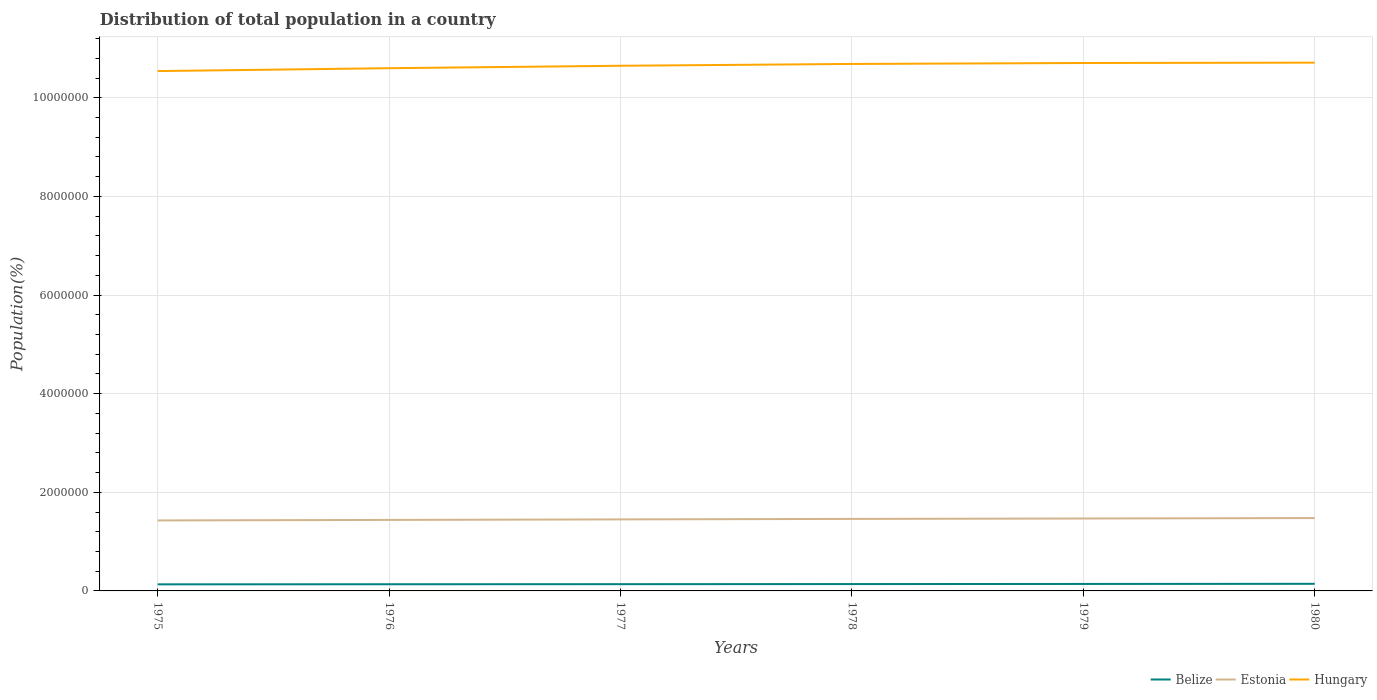Is the number of lines equal to the number of legend labels?
Your answer should be compact. Yes. Across all years, what is the maximum population of in Estonia?
Offer a very short reply. 1.43e+06. In which year was the population of in Estonia maximum?
Provide a short and direct response. 1975. What is the total population of in Belize in the graph?
Your answer should be very brief. -1.09e+04. What is the difference between the highest and the second highest population of in Belize?
Offer a terse response. 1.09e+04. Is the population of in Hungary strictly greater than the population of in Estonia over the years?
Offer a terse response. No. What is the difference between two consecutive major ticks on the Y-axis?
Give a very brief answer. 2.00e+06. How many legend labels are there?
Your answer should be very brief. 3. What is the title of the graph?
Provide a short and direct response. Distribution of total population in a country. What is the label or title of the Y-axis?
Give a very brief answer. Population(%). What is the Population(%) in Belize in 1975?
Your answer should be very brief. 1.33e+05. What is the Population(%) of Estonia in 1975?
Provide a succinct answer. 1.43e+06. What is the Population(%) in Hungary in 1975?
Provide a short and direct response. 1.05e+07. What is the Population(%) of Belize in 1976?
Offer a terse response. 1.35e+05. What is the Population(%) of Estonia in 1976?
Make the answer very short. 1.44e+06. What is the Population(%) in Hungary in 1976?
Ensure brevity in your answer.  1.06e+07. What is the Population(%) of Belize in 1977?
Give a very brief answer. 1.37e+05. What is the Population(%) in Estonia in 1977?
Your response must be concise. 1.45e+06. What is the Population(%) of Hungary in 1977?
Provide a short and direct response. 1.06e+07. What is the Population(%) in Belize in 1978?
Your answer should be very brief. 1.39e+05. What is the Population(%) of Estonia in 1978?
Your answer should be very brief. 1.46e+06. What is the Population(%) of Hungary in 1978?
Your answer should be compact. 1.07e+07. What is the Population(%) of Belize in 1979?
Offer a terse response. 1.41e+05. What is the Population(%) in Estonia in 1979?
Ensure brevity in your answer.  1.47e+06. What is the Population(%) in Hungary in 1979?
Make the answer very short. 1.07e+07. What is the Population(%) of Belize in 1980?
Give a very brief answer. 1.44e+05. What is the Population(%) in Estonia in 1980?
Your answer should be compact. 1.48e+06. What is the Population(%) of Hungary in 1980?
Offer a very short reply. 1.07e+07. Across all years, what is the maximum Population(%) in Belize?
Your answer should be compact. 1.44e+05. Across all years, what is the maximum Population(%) of Estonia?
Give a very brief answer. 1.48e+06. Across all years, what is the maximum Population(%) in Hungary?
Provide a succinct answer. 1.07e+07. Across all years, what is the minimum Population(%) of Belize?
Give a very brief answer. 1.33e+05. Across all years, what is the minimum Population(%) of Estonia?
Keep it short and to the point. 1.43e+06. Across all years, what is the minimum Population(%) of Hungary?
Ensure brevity in your answer.  1.05e+07. What is the total Population(%) of Belize in the graph?
Keep it short and to the point. 8.30e+05. What is the total Population(%) in Estonia in the graph?
Offer a terse response. 8.72e+06. What is the total Population(%) in Hungary in the graph?
Your answer should be compact. 6.39e+07. What is the difference between the Population(%) of Belize in 1975 and that in 1976?
Provide a short and direct response. -1884. What is the difference between the Population(%) in Estonia in 1975 and that in 1976?
Provide a short and direct response. -1.02e+04. What is the difference between the Population(%) in Hungary in 1975 and that in 1976?
Offer a terse response. -5.82e+04. What is the difference between the Population(%) of Belize in 1975 and that in 1977?
Your response must be concise. -3730. What is the difference between the Population(%) of Estonia in 1975 and that in 1977?
Provide a succinct answer. -2.09e+04. What is the difference between the Population(%) in Hungary in 1975 and that in 1977?
Make the answer very short. -1.08e+05. What is the difference between the Population(%) in Belize in 1975 and that in 1978?
Your answer should be compact. -5711. What is the difference between the Population(%) of Estonia in 1975 and that in 1978?
Keep it short and to the point. -3.08e+04. What is the difference between the Population(%) of Hungary in 1975 and that in 1978?
Provide a short and direct response. -1.44e+05. What is the difference between the Population(%) in Belize in 1975 and that in 1979?
Keep it short and to the point. -8047. What is the difference between the Population(%) of Estonia in 1975 and that in 1979?
Give a very brief answer. -3.90e+04. What is the difference between the Population(%) of Hungary in 1975 and that in 1979?
Give a very brief answer. -1.64e+05. What is the difference between the Population(%) in Belize in 1975 and that in 1980?
Provide a succinct answer. -1.09e+04. What is the difference between the Population(%) in Estonia in 1975 and that in 1980?
Make the answer very short. -4.79e+04. What is the difference between the Population(%) of Hungary in 1975 and that in 1980?
Give a very brief answer. -1.71e+05. What is the difference between the Population(%) in Belize in 1976 and that in 1977?
Provide a short and direct response. -1846. What is the difference between the Population(%) of Estonia in 1976 and that in 1977?
Provide a succinct answer. -1.06e+04. What is the difference between the Population(%) in Hungary in 1976 and that in 1977?
Your response must be concise. -4.94e+04. What is the difference between the Population(%) in Belize in 1976 and that in 1978?
Your answer should be very brief. -3827. What is the difference between the Population(%) of Estonia in 1976 and that in 1978?
Provide a short and direct response. -2.06e+04. What is the difference between the Population(%) of Hungary in 1976 and that in 1978?
Ensure brevity in your answer.  -8.61e+04. What is the difference between the Population(%) of Belize in 1976 and that in 1979?
Your response must be concise. -6163. What is the difference between the Population(%) of Estonia in 1976 and that in 1979?
Provide a succinct answer. -2.88e+04. What is the difference between the Population(%) in Hungary in 1976 and that in 1979?
Keep it short and to the point. -1.05e+05. What is the difference between the Population(%) in Belize in 1976 and that in 1980?
Give a very brief answer. -9006. What is the difference between the Population(%) of Estonia in 1976 and that in 1980?
Provide a short and direct response. -3.76e+04. What is the difference between the Population(%) in Hungary in 1976 and that in 1980?
Make the answer very short. -1.12e+05. What is the difference between the Population(%) of Belize in 1977 and that in 1978?
Your response must be concise. -1981. What is the difference between the Population(%) in Estonia in 1977 and that in 1978?
Offer a very short reply. -9977. What is the difference between the Population(%) in Hungary in 1977 and that in 1978?
Give a very brief answer. -3.68e+04. What is the difference between the Population(%) in Belize in 1977 and that in 1979?
Your answer should be very brief. -4317. What is the difference between the Population(%) in Estonia in 1977 and that in 1979?
Make the answer very short. -1.81e+04. What is the difference between the Population(%) of Hungary in 1977 and that in 1979?
Your response must be concise. -5.61e+04. What is the difference between the Population(%) of Belize in 1977 and that in 1980?
Your answer should be compact. -7160. What is the difference between the Population(%) in Estonia in 1977 and that in 1980?
Provide a succinct answer. -2.70e+04. What is the difference between the Population(%) of Hungary in 1977 and that in 1980?
Provide a succinct answer. -6.31e+04. What is the difference between the Population(%) in Belize in 1978 and that in 1979?
Provide a short and direct response. -2336. What is the difference between the Population(%) in Estonia in 1978 and that in 1979?
Your answer should be compact. -8145. What is the difference between the Population(%) in Hungary in 1978 and that in 1979?
Provide a succinct answer. -1.93e+04. What is the difference between the Population(%) of Belize in 1978 and that in 1980?
Give a very brief answer. -5179. What is the difference between the Population(%) of Estonia in 1978 and that in 1980?
Make the answer very short. -1.70e+04. What is the difference between the Population(%) in Hungary in 1978 and that in 1980?
Offer a very short reply. -2.63e+04. What is the difference between the Population(%) of Belize in 1979 and that in 1980?
Your response must be concise. -2843. What is the difference between the Population(%) in Estonia in 1979 and that in 1980?
Keep it short and to the point. -8886. What is the difference between the Population(%) of Hungary in 1979 and that in 1980?
Your answer should be compact. -6970. What is the difference between the Population(%) of Belize in 1975 and the Population(%) of Estonia in 1976?
Ensure brevity in your answer.  -1.31e+06. What is the difference between the Population(%) in Belize in 1975 and the Population(%) in Hungary in 1976?
Ensure brevity in your answer.  -1.05e+07. What is the difference between the Population(%) of Estonia in 1975 and the Population(%) of Hungary in 1976?
Your answer should be very brief. -9.17e+06. What is the difference between the Population(%) of Belize in 1975 and the Population(%) of Estonia in 1977?
Offer a very short reply. -1.32e+06. What is the difference between the Population(%) in Belize in 1975 and the Population(%) in Hungary in 1977?
Give a very brief answer. -1.05e+07. What is the difference between the Population(%) in Estonia in 1975 and the Population(%) in Hungary in 1977?
Provide a short and direct response. -9.22e+06. What is the difference between the Population(%) of Belize in 1975 and the Population(%) of Estonia in 1978?
Ensure brevity in your answer.  -1.33e+06. What is the difference between the Population(%) in Belize in 1975 and the Population(%) in Hungary in 1978?
Your response must be concise. -1.06e+07. What is the difference between the Population(%) in Estonia in 1975 and the Population(%) in Hungary in 1978?
Your response must be concise. -9.26e+06. What is the difference between the Population(%) of Belize in 1975 and the Population(%) of Estonia in 1979?
Your response must be concise. -1.34e+06. What is the difference between the Population(%) in Belize in 1975 and the Population(%) in Hungary in 1979?
Provide a short and direct response. -1.06e+07. What is the difference between the Population(%) in Estonia in 1975 and the Population(%) in Hungary in 1979?
Ensure brevity in your answer.  -9.27e+06. What is the difference between the Population(%) in Belize in 1975 and the Population(%) in Estonia in 1980?
Your answer should be very brief. -1.34e+06. What is the difference between the Population(%) of Belize in 1975 and the Population(%) of Hungary in 1980?
Your response must be concise. -1.06e+07. What is the difference between the Population(%) of Estonia in 1975 and the Population(%) of Hungary in 1980?
Provide a short and direct response. -9.28e+06. What is the difference between the Population(%) of Belize in 1976 and the Population(%) of Estonia in 1977?
Offer a very short reply. -1.32e+06. What is the difference between the Population(%) in Belize in 1976 and the Population(%) in Hungary in 1977?
Your response must be concise. -1.05e+07. What is the difference between the Population(%) of Estonia in 1976 and the Population(%) of Hungary in 1977?
Your answer should be compact. -9.21e+06. What is the difference between the Population(%) in Belize in 1976 and the Population(%) in Estonia in 1978?
Offer a terse response. -1.33e+06. What is the difference between the Population(%) of Belize in 1976 and the Population(%) of Hungary in 1978?
Your answer should be compact. -1.05e+07. What is the difference between the Population(%) in Estonia in 1976 and the Population(%) in Hungary in 1978?
Provide a short and direct response. -9.25e+06. What is the difference between the Population(%) of Belize in 1976 and the Population(%) of Estonia in 1979?
Give a very brief answer. -1.33e+06. What is the difference between the Population(%) in Belize in 1976 and the Population(%) in Hungary in 1979?
Your answer should be compact. -1.06e+07. What is the difference between the Population(%) in Estonia in 1976 and the Population(%) in Hungary in 1979?
Your answer should be very brief. -9.26e+06. What is the difference between the Population(%) in Belize in 1976 and the Population(%) in Estonia in 1980?
Provide a succinct answer. -1.34e+06. What is the difference between the Population(%) of Belize in 1976 and the Population(%) of Hungary in 1980?
Provide a short and direct response. -1.06e+07. What is the difference between the Population(%) in Estonia in 1976 and the Population(%) in Hungary in 1980?
Keep it short and to the point. -9.27e+06. What is the difference between the Population(%) in Belize in 1977 and the Population(%) in Estonia in 1978?
Offer a very short reply. -1.32e+06. What is the difference between the Population(%) of Belize in 1977 and the Population(%) of Hungary in 1978?
Keep it short and to the point. -1.05e+07. What is the difference between the Population(%) in Estonia in 1977 and the Population(%) in Hungary in 1978?
Ensure brevity in your answer.  -9.23e+06. What is the difference between the Population(%) of Belize in 1977 and the Population(%) of Estonia in 1979?
Keep it short and to the point. -1.33e+06. What is the difference between the Population(%) in Belize in 1977 and the Population(%) in Hungary in 1979?
Give a very brief answer. -1.06e+07. What is the difference between the Population(%) of Estonia in 1977 and the Population(%) of Hungary in 1979?
Your answer should be compact. -9.25e+06. What is the difference between the Population(%) in Belize in 1977 and the Population(%) in Estonia in 1980?
Keep it short and to the point. -1.34e+06. What is the difference between the Population(%) of Belize in 1977 and the Population(%) of Hungary in 1980?
Make the answer very short. -1.06e+07. What is the difference between the Population(%) of Estonia in 1977 and the Population(%) of Hungary in 1980?
Give a very brief answer. -9.26e+06. What is the difference between the Population(%) in Belize in 1978 and the Population(%) in Estonia in 1979?
Provide a short and direct response. -1.33e+06. What is the difference between the Population(%) of Belize in 1978 and the Population(%) of Hungary in 1979?
Your answer should be very brief. -1.06e+07. What is the difference between the Population(%) in Estonia in 1978 and the Population(%) in Hungary in 1979?
Offer a terse response. -9.24e+06. What is the difference between the Population(%) of Belize in 1978 and the Population(%) of Estonia in 1980?
Make the answer very short. -1.34e+06. What is the difference between the Population(%) in Belize in 1978 and the Population(%) in Hungary in 1980?
Keep it short and to the point. -1.06e+07. What is the difference between the Population(%) of Estonia in 1978 and the Population(%) of Hungary in 1980?
Your answer should be compact. -9.25e+06. What is the difference between the Population(%) of Belize in 1979 and the Population(%) of Estonia in 1980?
Your answer should be compact. -1.34e+06. What is the difference between the Population(%) in Belize in 1979 and the Population(%) in Hungary in 1980?
Offer a terse response. -1.06e+07. What is the difference between the Population(%) in Estonia in 1979 and the Population(%) in Hungary in 1980?
Your answer should be compact. -9.24e+06. What is the average Population(%) of Belize per year?
Keep it short and to the point. 1.38e+05. What is the average Population(%) in Estonia per year?
Provide a short and direct response. 1.45e+06. What is the average Population(%) in Hungary per year?
Offer a very short reply. 1.06e+07. In the year 1975, what is the difference between the Population(%) in Belize and Population(%) in Estonia?
Ensure brevity in your answer.  -1.30e+06. In the year 1975, what is the difference between the Population(%) of Belize and Population(%) of Hungary?
Provide a short and direct response. -1.04e+07. In the year 1975, what is the difference between the Population(%) in Estonia and Population(%) in Hungary?
Ensure brevity in your answer.  -9.11e+06. In the year 1976, what is the difference between the Population(%) in Belize and Population(%) in Estonia?
Ensure brevity in your answer.  -1.30e+06. In the year 1976, what is the difference between the Population(%) in Belize and Population(%) in Hungary?
Offer a terse response. -1.05e+07. In the year 1976, what is the difference between the Population(%) in Estonia and Population(%) in Hungary?
Provide a short and direct response. -9.16e+06. In the year 1977, what is the difference between the Population(%) in Belize and Population(%) in Estonia?
Provide a succinct answer. -1.31e+06. In the year 1977, what is the difference between the Population(%) of Belize and Population(%) of Hungary?
Offer a terse response. -1.05e+07. In the year 1977, what is the difference between the Population(%) of Estonia and Population(%) of Hungary?
Give a very brief answer. -9.20e+06. In the year 1978, what is the difference between the Population(%) in Belize and Population(%) in Estonia?
Offer a terse response. -1.32e+06. In the year 1978, what is the difference between the Population(%) in Belize and Population(%) in Hungary?
Your response must be concise. -1.05e+07. In the year 1978, what is the difference between the Population(%) of Estonia and Population(%) of Hungary?
Offer a terse response. -9.22e+06. In the year 1979, what is the difference between the Population(%) in Belize and Population(%) in Estonia?
Make the answer very short. -1.33e+06. In the year 1979, what is the difference between the Population(%) in Belize and Population(%) in Hungary?
Ensure brevity in your answer.  -1.06e+07. In the year 1979, what is the difference between the Population(%) of Estonia and Population(%) of Hungary?
Offer a terse response. -9.24e+06. In the year 1980, what is the difference between the Population(%) in Belize and Population(%) in Estonia?
Give a very brief answer. -1.33e+06. In the year 1980, what is the difference between the Population(%) of Belize and Population(%) of Hungary?
Offer a very short reply. -1.06e+07. In the year 1980, what is the difference between the Population(%) of Estonia and Population(%) of Hungary?
Give a very brief answer. -9.23e+06. What is the ratio of the Population(%) of Belize in 1975 to that in 1976?
Offer a terse response. 0.99. What is the ratio of the Population(%) of Estonia in 1975 to that in 1976?
Your answer should be very brief. 0.99. What is the ratio of the Population(%) in Belize in 1975 to that in 1977?
Offer a terse response. 0.97. What is the ratio of the Population(%) of Estonia in 1975 to that in 1977?
Your response must be concise. 0.99. What is the ratio of the Population(%) in Belize in 1975 to that in 1978?
Offer a terse response. 0.96. What is the ratio of the Population(%) of Estonia in 1975 to that in 1978?
Provide a succinct answer. 0.98. What is the ratio of the Population(%) in Hungary in 1975 to that in 1978?
Your answer should be compact. 0.99. What is the ratio of the Population(%) in Belize in 1975 to that in 1979?
Give a very brief answer. 0.94. What is the ratio of the Population(%) of Estonia in 1975 to that in 1979?
Offer a very short reply. 0.97. What is the ratio of the Population(%) in Hungary in 1975 to that in 1979?
Give a very brief answer. 0.98. What is the ratio of the Population(%) of Belize in 1975 to that in 1980?
Provide a short and direct response. 0.92. What is the ratio of the Population(%) in Estonia in 1975 to that in 1980?
Make the answer very short. 0.97. What is the ratio of the Population(%) of Hungary in 1975 to that in 1980?
Provide a succinct answer. 0.98. What is the ratio of the Population(%) in Belize in 1976 to that in 1977?
Ensure brevity in your answer.  0.99. What is the ratio of the Population(%) in Estonia in 1976 to that in 1977?
Keep it short and to the point. 0.99. What is the ratio of the Population(%) of Hungary in 1976 to that in 1977?
Give a very brief answer. 1. What is the ratio of the Population(%) in Belize in 1976 to that in 1978?
Your response must be concise. 0.97. What is the ratio of the Population(%) in Estonia in 1976 to that in 1978?
Make the answer very short. 0.99. What is the ratio of the Population(%) in Hungary in 1976 to that in 1978?
Give a very brief answer. 0.99. What is the ratio of the Population(%) of Belize in 1976 to that in 1979?
Provide a succinct answer. 0.96. What is the ratio of the Population(%) of Estonia in 1976 to that in 1979?
Make the answer very short. 0.98. What is the ratio of the Population(%) of Estonia in 1976 to that in 1980?
Keep it short and to the point. 0.97. What is the ratio of the Population(%) in Hungary in 1976 to that in 1980?
Your response must be concise. 0.99. What is the ratio of the Population(%) of Belize in 1977 to that in 1978?
Offer a very short reply. 0.99. What is the ratio of the Population(%) in Estonia in 1977 to that in 1978?
Offer a very short reply. 0.99. What is the ratio of the Population(%) in Belize in 1977 to that in 1979?
Make the answer very short. 0.97. What is the ratio of the Population(%) of Estonia in 1977 to that in 1979?
Provide a short and direct response. 0.99. What is the ratio of the Population(%) of Belize in 1977 to that in 1980?
Make the answer very short. 0.95. What is the ratio of the Population(%) of Estonia in 1977 to that in 1980?
Offer a terse response. 0.98. What is the ratio of the Population(%) in Hungary in 1977 to that in 1980?
Provide a succinct answer. 0.99. What is the ratio of the Population(%) in Belize in 1978 to that in 1979?
Your answer should be compact. 0.98. What is the ratio of the Population(%) in Estonia in 1978 to that in 1979?
Offer a very short reply. 0.99. What is the ratio of the Population(%) in Hungary in 1978 to that in 1979?
Make the answer very short. 1. What is the ratio of the Population(%) in Belize in 1978 to that in 1980?
Ensure brevity in your answer.  0.96. What is the ratio of the Population(%) in Estonia in 1978 to that in 1980?
Ensure brevity in your answer.  0.99. What is the ratio of the Population(%) in Hungary in 1978 to that in 1980?
Make the answer very short. 1. What is the ratio of the Population(%) in Belize in 1979 to that in 1980?
Your answer should be compact. 0.98. What is the ratio of the Population(%) in Estonia in 1979 to that in 1980?
Provide a succinct answer. 0.99. What is the difference between the highest and the second highest Population(%) in Belize?
Your answer should be compact. 2843. What is the difference between the highest and the second highest Population(%) of Estonia?
Provide a succinct answer. 8886. What is the difference between the highest and the second highest Population(%) of Hungary?
Ensure brevity in your answer.  6970. What is the difference between the highest and the lowest Population(%) of Belize?
Provide a succinct answer. 1.09e+04. What is the difference between the highest and the lowest Population(%) of Estonia?
Keep it short and to the point. 4.79e+04. What is the difference between the highest and the lowest Population(%) of Hungary?
Provide a succinct answer. 1.71e+05. 